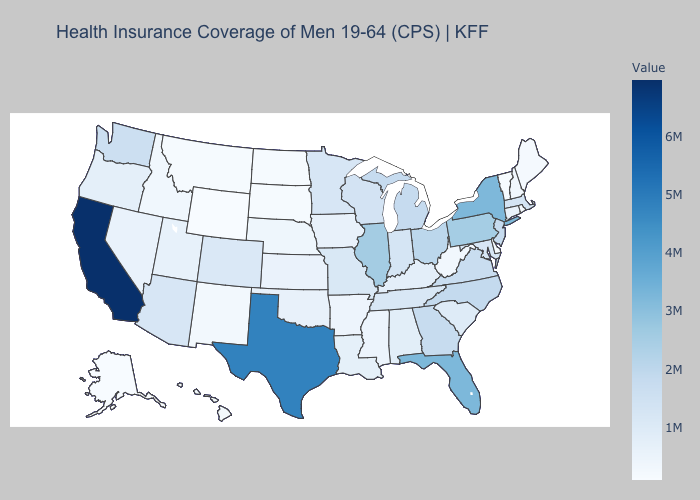Does California have the highest value in the West?
Answer briefly. Yes. Among the states that border Nebraska , does Colorado have the highest value?
Give a very brief answer. No. Is the legend a continuous bar?
Write a very short answer. Yes. 